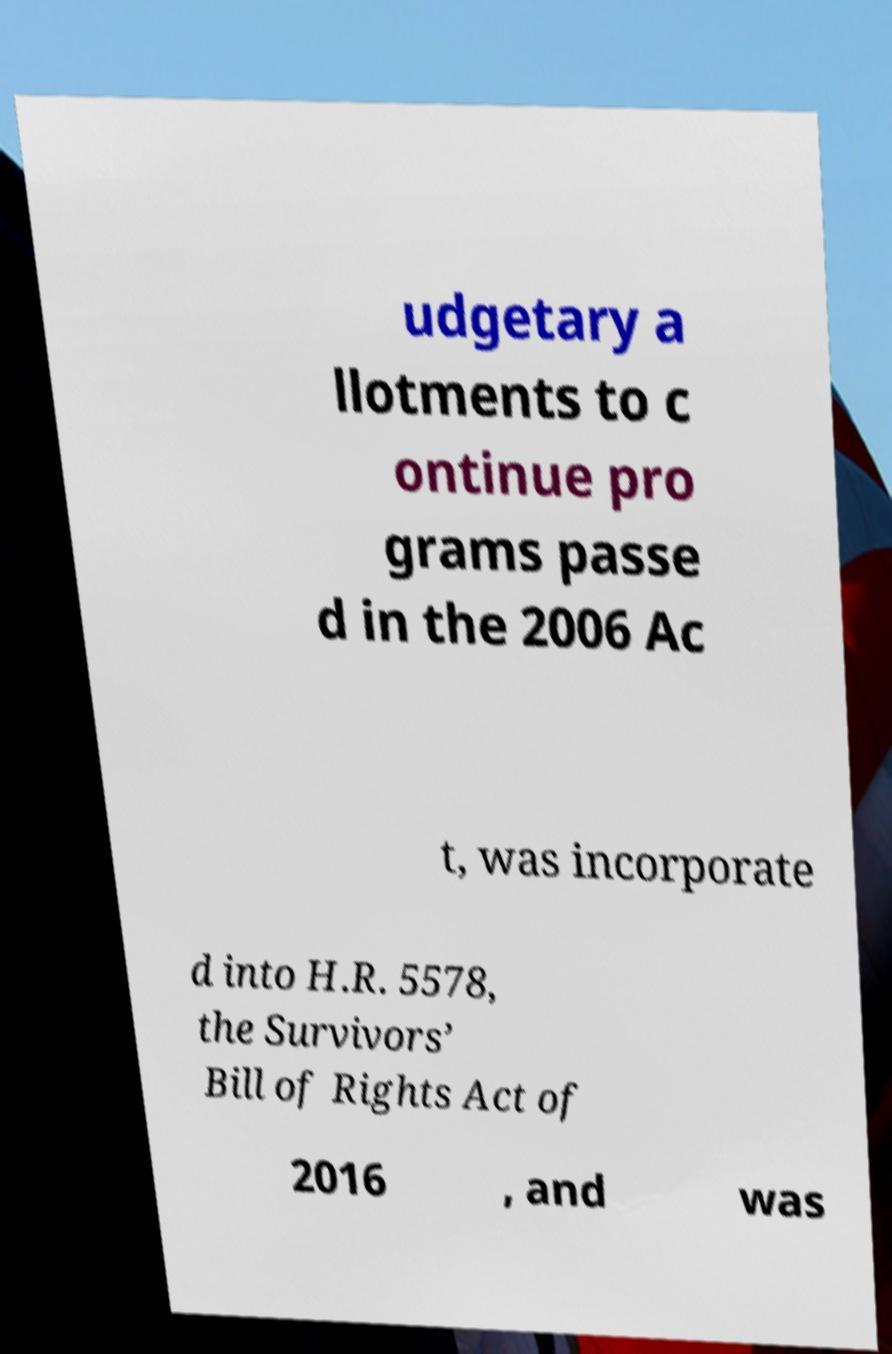There's text embedded in this image that I need extracted. Can you transcribe it verbatim? udgetary a llotments to c ontinue pro grams passe d in the 2006 Ac t, was incorporate d into H.R. 5578, the Survivors’ Bill of Rights Act of 2016 , and was 